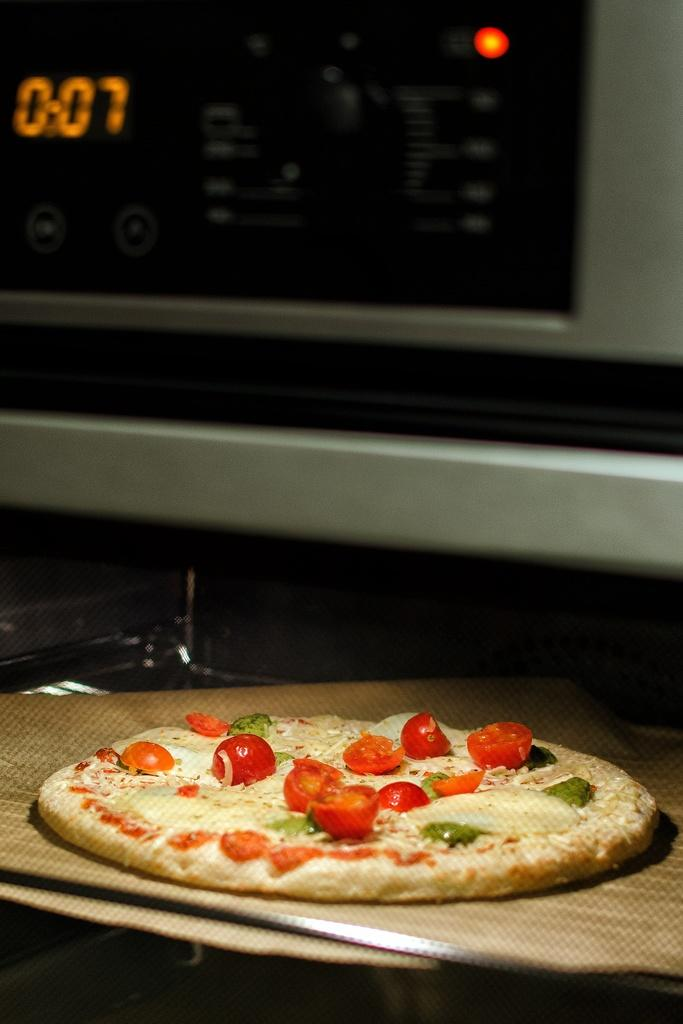<image>
Create a compact narrative representing the image presented. A pizza oven displaying 0.07 and a pizza on the counter. 